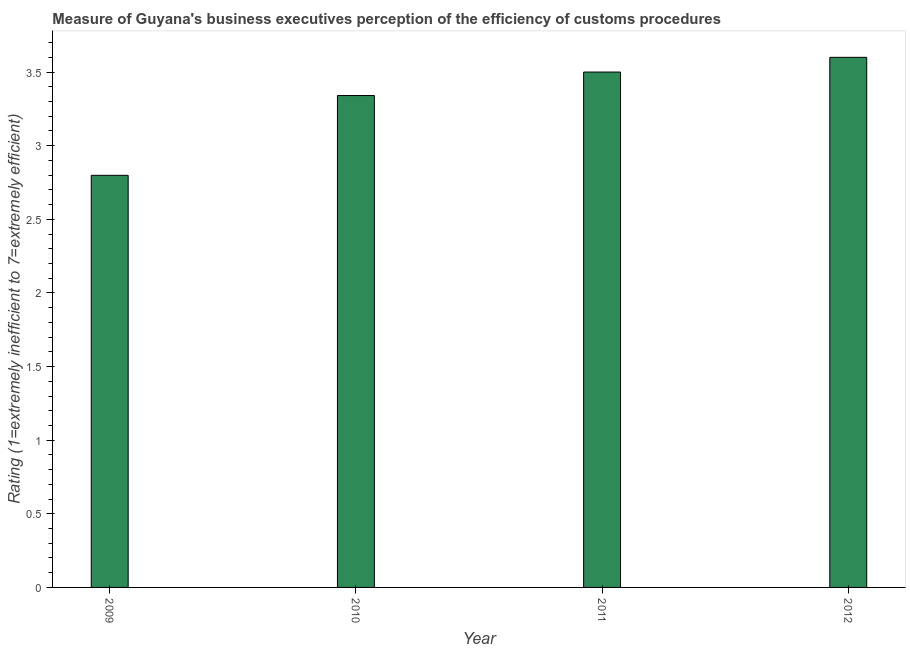Does the graph contain any zero values?
Offer a very short reply. No. Does the graph contain grids?
Make the answer very short. No. What is the title of the graph?
Provide a short and direct response. Measure of Guyana's business executives perception of the efficiency of customs procedures. What is the label or title of the X-axis?
Ensure brevity in your answer.  Year. What is the label or title of the Y-axis?
Provide a short and direct response. Rating (1=extremely inefficient to 7=extremely efficient). What is the rating measuring burden of customs procedure in 2009?
Offer a very short reply. 2.8. Across all years, what is the maximum rating measuring burden of customs procedure?
Your response must be concise. 3.6. Across all years, what is the minimum rating measuring burden of customs procedure?
Make the answer very short. 2.8. What is the sum of the rating measuring burden of customs procedure?
Ensure brevity in your answer.  13.24. What is the average rating measuring burden of customs procedure per year?
Ensure brevity in your answer.  3.31. What is the median rating measuring burden of customs procedure?
Provide a succinct answer. 3.42. In how many years, is the rating measuring burden of customs procedure greater than 2.9 ?
Your response must be concise. 3. What is the ratio of the rating measuring burden of customs procedure in 2011 to that in 2012?
Your answer should be very brief. 0.97. Is the rating measuring burden of customs procedure in 2009 less than that in 2012?
Your answer should be compact. Yes. In how many years, is the rating measuring burden of customs procedure greater than the average rating measuring burden of customs procedure taken over all years?
Give a very brief answer. 3. How many bars are there?
Provide a succinct answer. 4. How many years are there in the graph?
Provide a succinct answer. 4. What is the difference between two consecutive major ticks on the Y-axis?
Your answer should be compact. 0.5. What is the Rating (1=extremely inefficient to 7=extremely efficient) in 2009?
Your answer should be very brief. 2.8. What is the Rating (1=extremely inefficient to 7=extremely efficient) of 2010?
Your answer should be very brief. 3.34. What is the Rating (1=extremely inefficient to 7=extremely efficient) in 2011?
Your response must be concise. 3.5. What is the Rating (1=extremely inefficient to 7=extremely efficient) of 2012?
Ensure brevity in your answer.  3.6. What is the difference between the Rating (1=extremely inefficient to 7=extremely efficient) in 2009 and 2010?
Offer a terse response. -0.54. What is the difference between the Rating (1=extremely inefficient to 7=extremely efficient) in 2009 and 2011?
Offer a terse response. -0.7. What is the difference between the Rating (1=extremely inefficient to 7=extremely efficient) in 2009 and 2012?
Make the answer very short. -0.8. What is the difference between the Rating (1=extremely inefficient to 7=extremely efficient) in 2010 and 2011?
Provide a succinct answer. -0.16. What is the difference between the Rating (1=extremely inefficient to 7=extremely efficient) in 2010 and 2012?
Provide a short and direct response. -0.26. What is the ratio of the Rating (1=extremely inefficient to 7=extremely efficient) in 2009 to that in 2010?
Your response must be concise. 0.84. What is the ratio of the Rating (1=extremely inefficient to 7=extremely efficient) in 2009 to that in 2012?
Your response must be concise. 0.78. What is the ratio of the Rating (1=extremely inefficient to 7=extremely efficient) in 2010 to that in 2011?
Ensure brevity in your answer.  0.95. What is the ratio of the Rating (1=extremely inefficient to 7=extremely efficient) in 2010 to that in 2012?
Give a very brief answer. 0.93. 